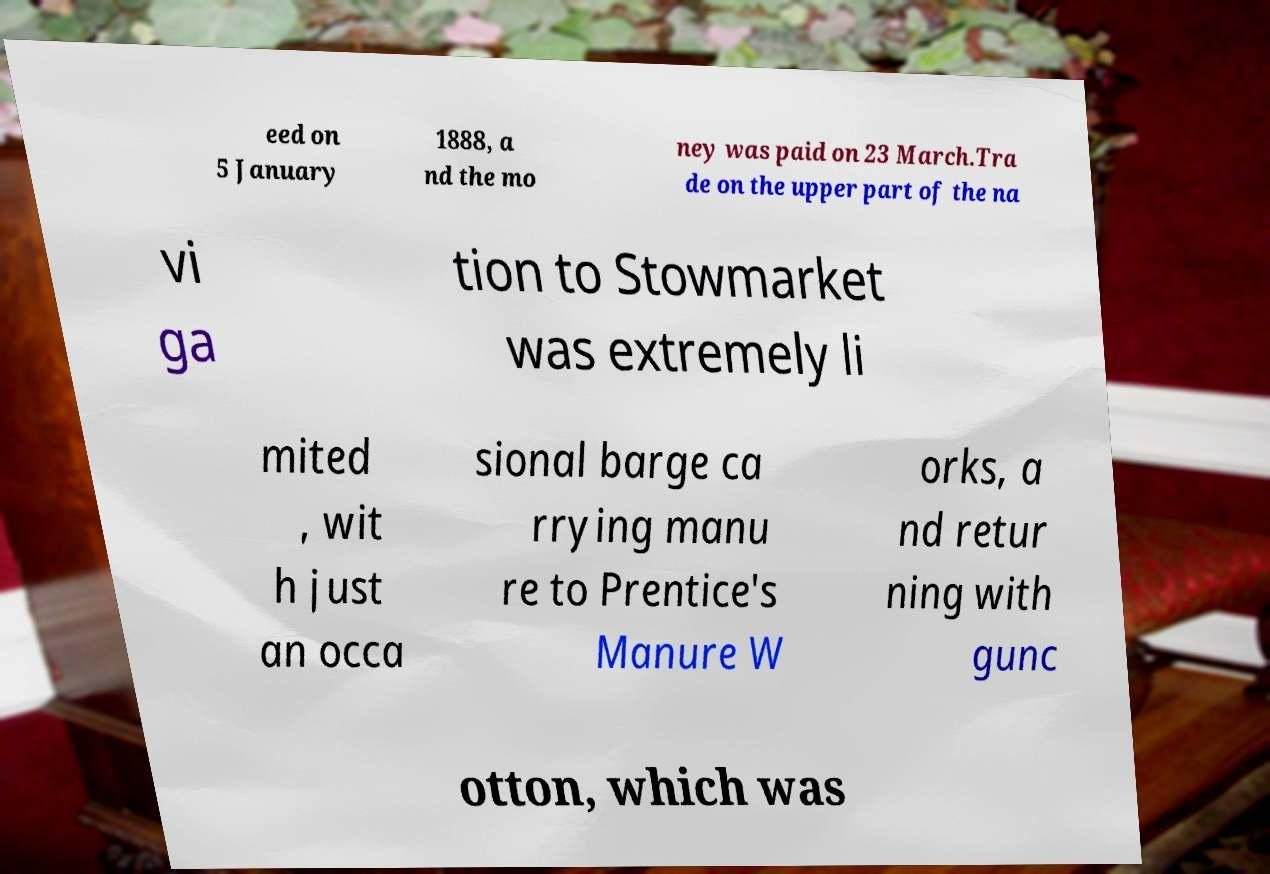What messages or text are displayed in this image? I need them in a readable, typed format. eed on 5 January 1888, a nd the mo ney was paid on 23 March.Tra de on the upper part of the na vi ga tion to Stowmarket was extremely li mited , wit h just an occa sional barge ca rrying manu re to Prentice's Manure W orks, a nd retur ning with gunc otton, which was 